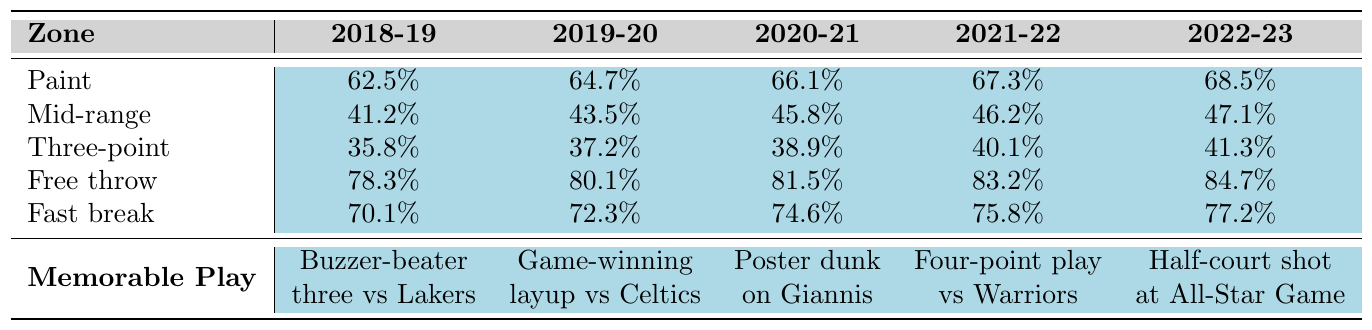What was the shot accuracy for three-point shots in the 2021-22 season? Looking at the table, the value for three-point shooting in the 2021-22 season is listed as 40.1%.
Answer: 40.1% Which season had the highest free throw percentage? By checking the table, I see that the highest free throw percentage was in the 2022-23 season, which is 84.7%.
Answer: 84.7% What is the difference in paint shot accuracy between the 2018-19 and 2022-23 seasons? The paint shot accuracy in 2018-19 is 62.5%, and in 2022-23 it is 68.5%. To find the difference: 68.5% - 62.5% = 6%.
Answer: 6% Was the player's mid-range shot accuracy above 45% in the 2020-21 season? The mid-range shot accuracy for the 2020-21 season is 45.8%. Since this value is indeed above 45%, the answer is yes.
Answer: Yes What was the average free throw percentage over the five seasons? To find the average free throw percentage, add the free throw percentages across all five seasons: (78.3 + 80.1 + 81.5 + 83.2 + 84.7) = 407.8%. Then divide by 5: 407.8% / 5 = 81.56%.
Answer: 81.56% In which season did the player shoot the highest percentage from the fast break? Upon examining the table, the shooting percentage for fast breaks was highest in the 2022-23 season at 77.2%.
Answer: 2022-23 What is the trend in three-point shooting accuracy across the five seasons? Reviewing the three-point shooting accuracies from 2018-19 (35.8%) to 2022-23 (41.3%), it shows a steady increase each season, indicating improvement.
Answer: Steady increase How much did the mid-range shot percentage increase from the 2019-20 season to the 2021-22 season? The mid-range percentage in 2019-20 is 43.5% and in 2021-22 is 46.2%. The increase can be calculated as 46.2% - 43.5% = 2.7%.
Answer: 2.7% Which zone had the lowest shot accuracy in the 2018-19 season? The table indicates that the zone with the lowest shot accuracy in the 2018-19 season was the three-point zone at 35.8%.
Answer: Three-point zone How does the accuracy for fast break shots compare between the 2020-21 and 2021-22 seasons? The fast break shot accuracy in 2020-21 is 74.6%, whereas in 2021-22 it is 75.8%. Comparing these shows an increase of 1.2%.
Answer: Increased by 1.2% 